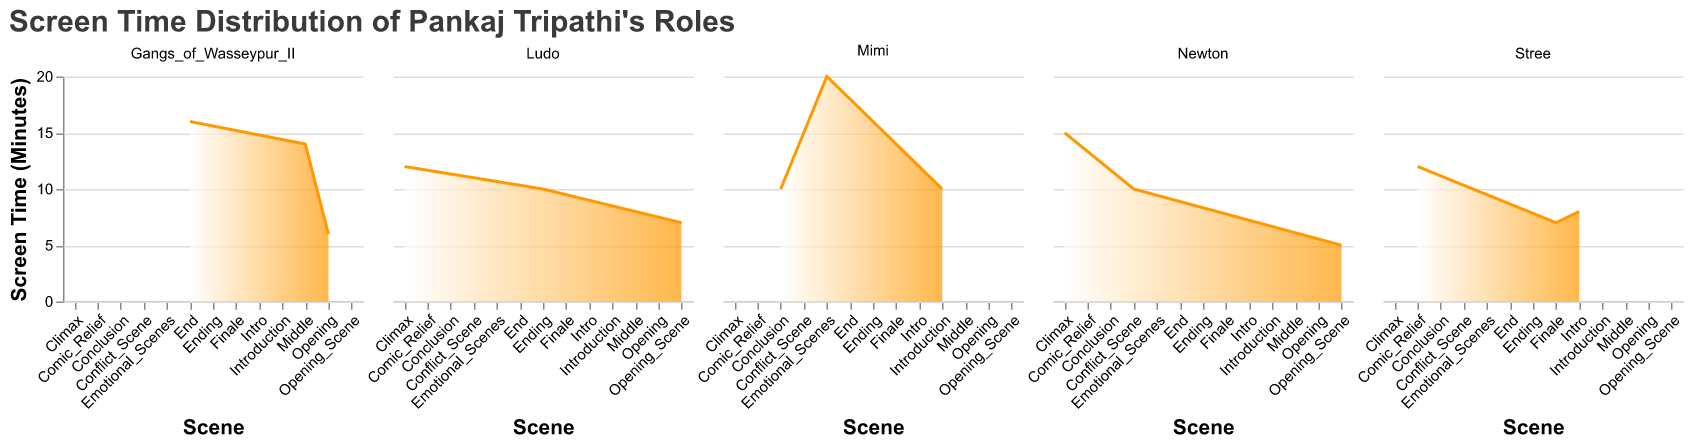How is the screen time distributed for the movie "Newton"? The screen time is spread across three scenes in "Newton" with 5 minutes in the Opening Scene, 10 minutes in the Conflict Scene, and 15 minutes in the Climax.
Answer: Opening Scene: 5 minutes, Conflict Scene: 10 minutes, Climax: 15 minutes Which movie has the highest screen time allocation for a single scene, and which scene is it? From the plot, "Mimi" has the highest screen time allocation for a single scene, with 20 minutes dedicated to the Emotional Scenes.
Answer: "Mimi", Emotional Scenes Among all movies, which scene type has the minimum screen time? Looking at all the subplots, the scene with the least screen time is the Opening Scene of "Newton" with 5 minutes.
Answer: Opening Scene of "Newton" Compare the screen time of the Opening Scenes across all movies. Which movie has the longest Opening Scene? By comparing the Opening Scenes across "Newton" (5 minutes), "Gangs of Wasseypur II" (6 minutes), and "Ludo" (7 minutes), "Ludo" has the longest Opening Scene.
Answer: "Ludo", 7 minutes How does the total screen time of "Stree" compare to that of "Newton"? To find the total screen time, add the screen time of each scene in both movies. "Stree" has 8 (Intro) + 12 (Comic Relief) + 7 (Finale) = 27 minutes. "Newton" has 5 (Opening Scene) + 10 (Conflict Scene) + 15 (Climax) = 30 minutes.
Answer: "Newton" has 3 minutes more than "Stree" What is the average screen time per scene for the movie "Gangs of Wasseypur II"? The total screen time for "Gangs of Wasseypur II" is 6 (Opening) + 14 (Middle) + 16 (End) = 36 minutes. There are 3 scenes, so the average screen time is 36/3 = 12 minutes per scene.
Answer: 12 minutes Which movie has the most evenly distributed screen time across its scenes? By observing the areas of each subplot, "Mimi" has an even distribution of screen time with 10 (Introduction), 20 (Emotional Scenes) and 10 (Conclusion) = 40 minutes total, the variations are less compared to other movies.
Answer: "Mimi" In the movie "Ludo", which scene has the smallest screen time and by how much? The scenes in "Ludo" have the following screen times: Opening Scene (7 minutes), Climax (12 minutes), Ending (10 minutes). The smallest screen time is the Opening Scene with 7 minutes.
Answer: Opening Scene, 7 minutes What is the total screen time across all movies for their respective final scenes? Summing the screen times of the final scenes: "Newton" Climax (15), "Stree" Finale (7), "Gangs of Wasseypur II" End (16), "Mimi" Conclusion (10), "Ludo" Ending (10). Total = 15 + 7 + 16 + 10 + 10 = 58 minutes.
Answer: 58 minutes 